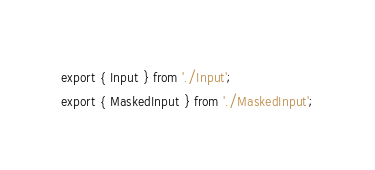<code> <loc_0><loc_0><loc_500><loc_500><_JavaScript_>export { Input } from './Input';
export { MaskedInput } from './MaskedInput';
</code> 